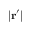<formula> <loc_0><loc_0><loc_500><loc_500>| r ^ { \prime } |</formula> 